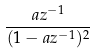<formula> <loc_0><loc_0><loc_500><loc_500>\frac { a z ^ { - 1 } } { ( 1 - a z ^ { - 1 } ) ^ { 2 } }</formula> 